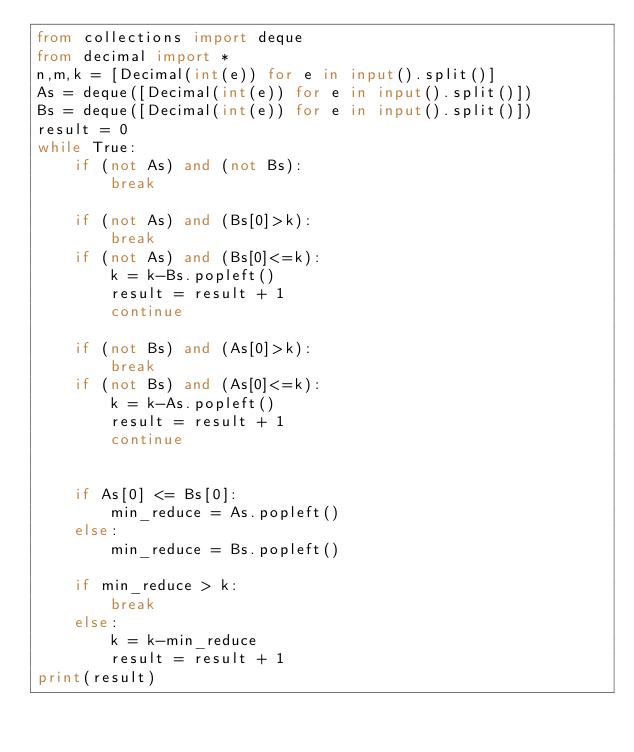<code> <loc_0><loc_0><loc_500><loc_500><_Python_>from collections import deque
from decimal import *
n,m,k = [Decimal(int(e)) for e in input().split()]
As = deque([Decimal(int(e)) for e in input().split()])
Bs = deque([Decimal(int(e)) for e in input().split()])
result = 0
while True:
    if (not As) and (not Bs):
        break
        
    if (not As) and (Bs[0]>k):
        break
    if (not As) and (Bs[0]<=k):
        k = k-Bs.popleft()
        result = result + 1
        continue
        
    if (not Bs) and (As[0]>k):
        break
    if (not Bs) and (As[0]<=k):
        k = k-As.popleft()
        result = result + 1
        continue
    
    
    if As[0] <= Bs[0]:
        min_reduce = As.popleft()
    else:
        min_reduce = Bs.popleft()

    if min_reduce > k:
        break
    else:
        k = k-min_reduce
        result = result + 1
print(result)</code> 